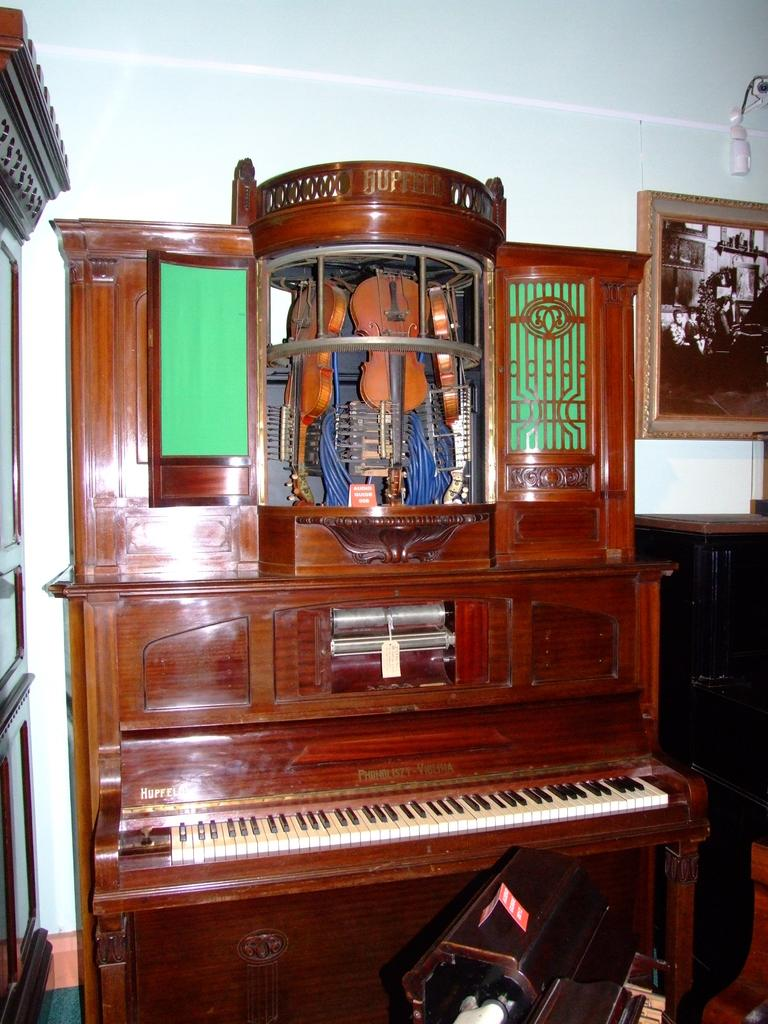What musical instrument is the main subject in the image? There is a piano in the image. What other musical instruments are visible in the image? There are three violins placed on top of the piano. Where is the scene in the image taking place? The scene is in a shop. How does the butter help the piano play in the image? There is no butter present in the image, and therefore it cannot help the piano play. 